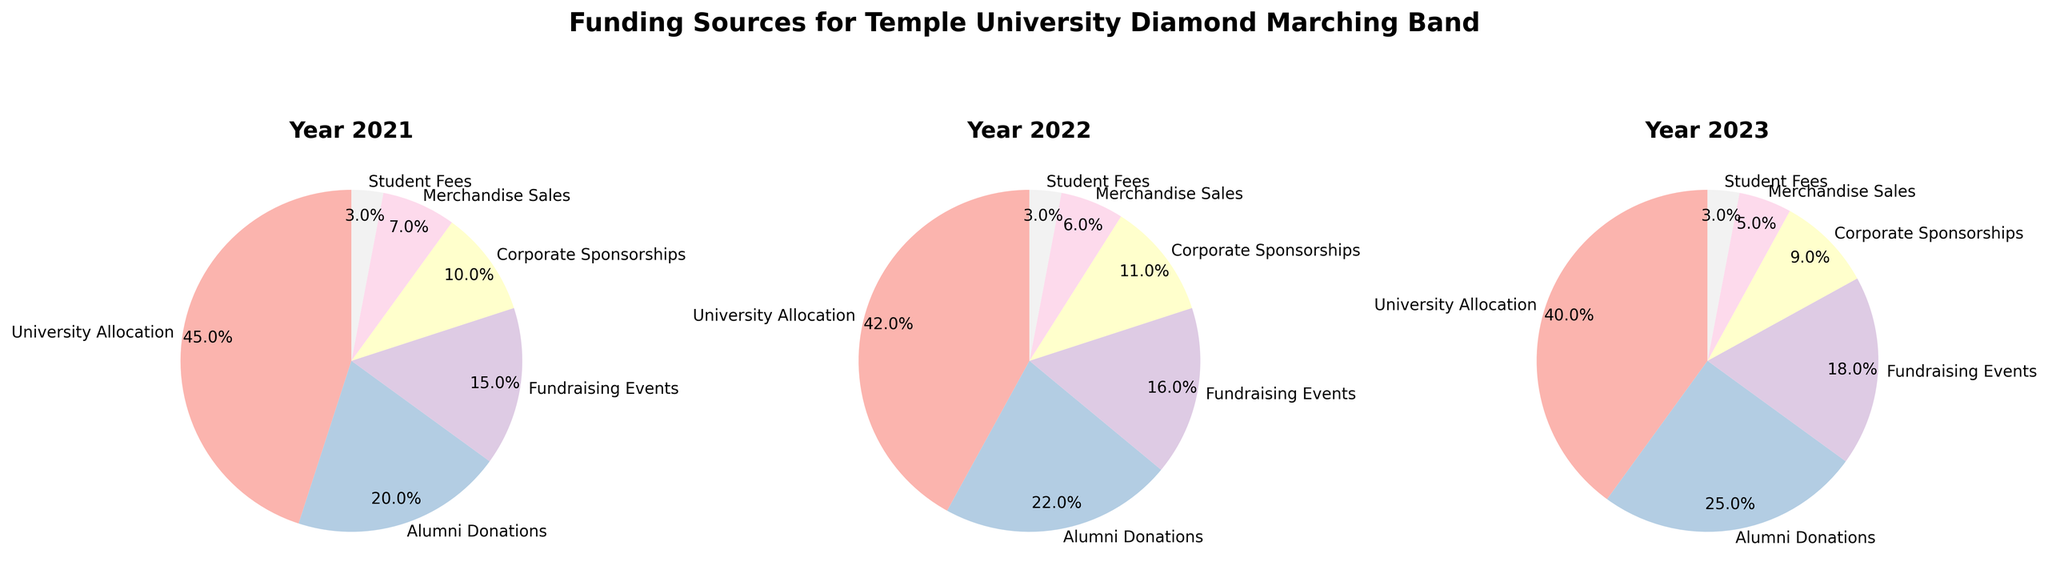What's the main funding source for the band in 2023? In the 2023 pie chart, the largest segment represents University Allocation, which means it is the main funding source.
Answer: University Allocation How does the percentage of Alumni Donations change from 2021 to 2023? Comparing the pie charts for 2021 and 2023, Alumni Donations increase from 20% in 2021 to 25% in 2023.
Answer: Increase by 5% Which year has the highest percentage of Corporate Sponsorships? Comparing all three pie charts, 2022 shows the highest percentage for Corporate Sponsorships, which is 11%.
Answer: 2022 What is the combined percentage of Student Fees and Merchandise Sales in 2022? In 2022, Student Fees are 3% and Merchandise Sales are 6%. Adding these percentages gives 3% + 6% = 9%.
Answer: 9% Is the percentage of University Allocation consistently decreasing over the years? Checking the pie charts for 2021, 2022, and 2023, University Allocation is 45%, 42%, and 40% respectively. This shows a consistent decrease each year.
Answer: Yes Which funding source always remains the same percentage from 2021 to 2023? Observing the pie charts, Student Fees are consistently at 3% in all three years.
Answer: Student Fees What’s the difference in percentage between Corporate Sponsorships and Fundraising Events in 2021? In 2021, Corporate Sponsorships are at 10% and Fundraising Events are at 15%. The difference is 15% - 10% = 5%.
Answer: 5% Which funding source shows the greatest percentage increase from 2021 to 2023? Comparing all funding sources, Alumni Donations increase from 20% to 25%, which is a 5% increase — the largest among all sources.
Answer: Alumni Donations What’s the trend in Merchandise Sales percentage from 2021 to 2023? The pie charts show Merchandise Sales decreasing from 7% in 2021 to 6% in 2022 and further to 5% in 2023.
Answer: Decreasing If you combine the percentages of Fundraising Events and Corporate Sponsorships for all three years, which year has the highest total percentage for these two sources? Adding the percentages for Fundraising Events and Corporate Sponsorships: in 2021, it's 15% + 10% = 25%; in 2022, it's 16% + 11% = 27%; in 2023, it's 18% + 9% = 27%. Both 2022 and 2023 have the highest total percentage of 27%.
Answer: 2022 and 2023 